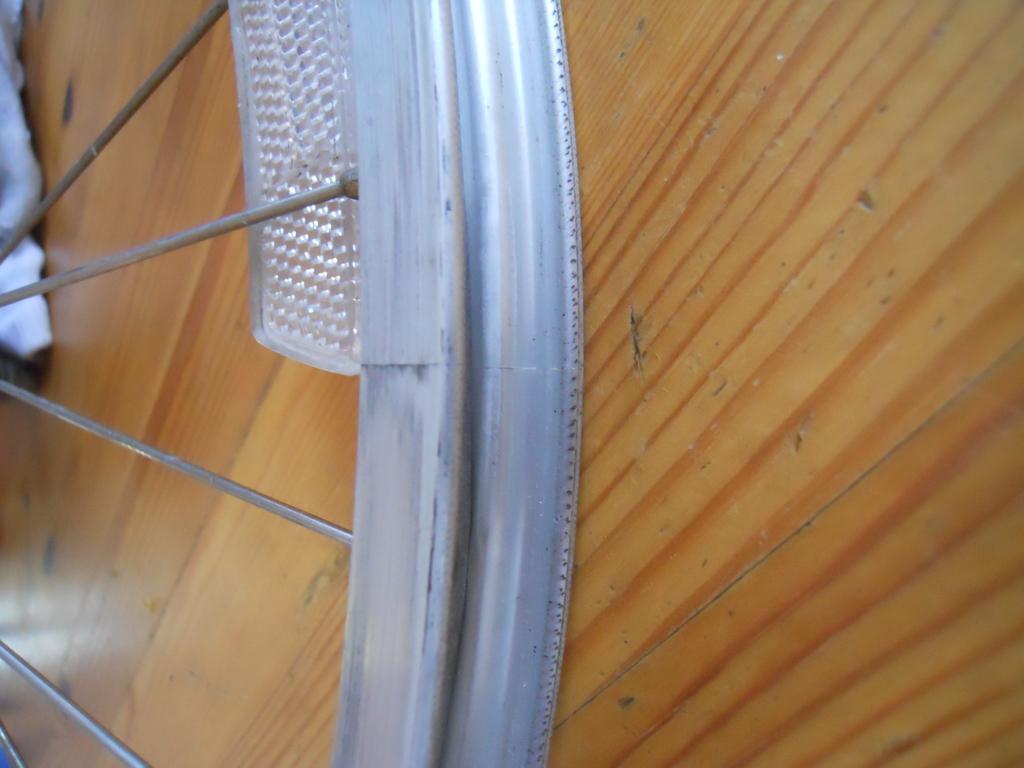How would you summarize this image in a sentence or two? In this picture we can see bicycle wheel without rubber which is placed on the wooden floor. On the top left corner we can see cloth. 